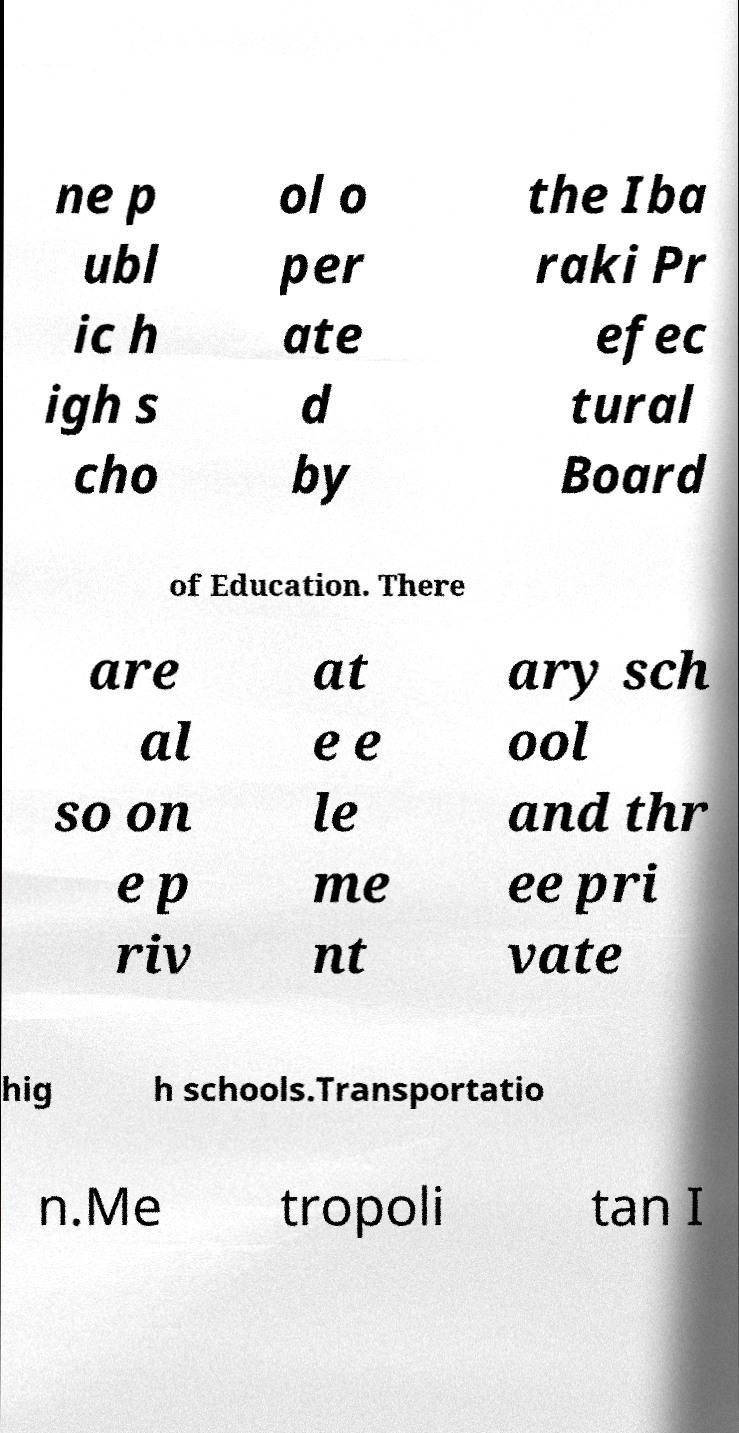Can you accurately transcribe the text from the provided image for me? ne p ubl ic h igh s cho ol o per ate d by the Iba raki Pr efec tural Board of Education. There are al so on e p riv at e e le me nt ary sch ool and thr ee pri vate hig h schools.Transportatio n.Me tropoli tan I 